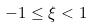<formula> <loc_0><loc_0><loc_500><loc_500>- 1 \leq \xi < 1</formula> 